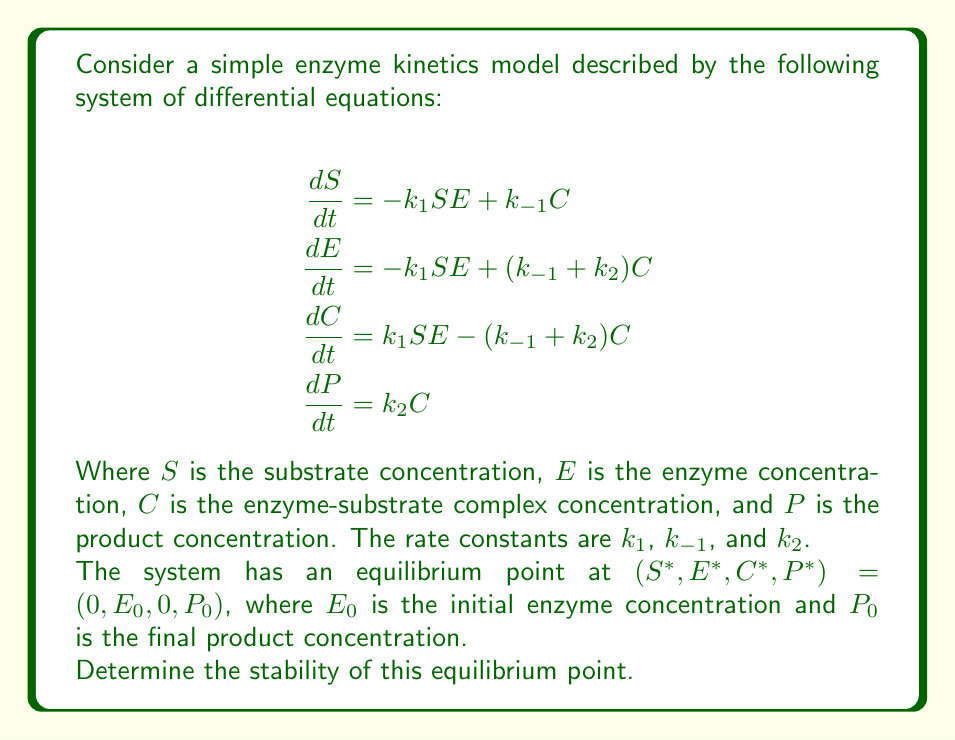Provide a solution to this math problem. To determine the stability of the equilibrium point, we need to follow these steps:

1. Calculate the Jacobian matrix of the system at the equilibrium point.
2. Find the eigenvalues of the Jacobian matrix.
3. Analyze the signs of the real parts of the eigenvalues.

Step 1: Calculate the Jacobian matrix

The Jacobian matrix is:

$$J = \begin{bmatrix}
\frac{\partial \dot{S}}{\partial S} & \frac{\partial \dot{S}}{\partial E} & \frac{\partial \dot{S}}{\partial C} & \frac{\partial \dot{S}}{\partial P} \\
\frac{\partial \dot{E}}{\partial S} & \frac{\partial \dot{E}}{\partial E} & \frac{\partial \dot{E}}{\partial C} & \frac{\partial \dot{E}}{\partial P} \\
\frac{\partial \dot{C}}{\partial S} & \frac{\partial \dot{C}}{\partial E} & \frac{\partial \dot{C}}{\partial C} & \frac{\partial \dot{C}}{\partial P} \\
\frac{\partial \dot{P}}{\partial S} & \frac{\partial \dot{P}}{\partial E} & \frac{\partial \dot{P}}{\partial C} & \frac{\partial \dot{P}}{\partial P}
\end{bmatrix}$$

At the equilibrium point $(0, E_0, 0, P_0)$, the Jacobian becomes:

$$J = \begin{bmatrix}
-k_1E_0 & 0 & k_{-1} & 0 \\
-k_1E_0 & 0 & k_{-1} + k_2 & 0 \\
k_1E_0 & 0 & -(k_{-1} + k_2) & 0 \\
0 & 0 & k_2 & 0
\end{bmatrix}$$

Step 2: Find the eigenvalues

To find the eigenvalues, we need to solve the characteristic equation:

$$\det(J - \lambda I) = 0$$

Expanding this determinant, we get:

$$\lambda^2(\lambda + k_1E_0)(\lambda + k_{-1} + k_2) = 0$$

The eigenvalues are:

$$\lambda_1 = 0 \text{ (double root)}$$
$$\lambda_2 = -k_1E_0$$
$$\lambda_3 = -(k_{-1} + k_2)$$

Step 3: Analyze the eigenvalues

For the equilibrium point to be stable, all eigenvalues must have negative real parts. In this case:

- $\lambda_1 = 0$ (double root): This indicates neutral stability in two directions.
- $\lambda_2 = -k_1E_0$: This is negative since $k_1$ and $E_0$ are positive constants.
- $\lambda_3 = -(k_{-1} + k_2)$: This is negative since $k_{-1}$ and $k_2$ are positive constants.

The presence of zero eigenvalues (neutral stability) means that the equilibrium point is not asymptotically stable. However, it is still considered stable in the sense of Lyapunov, as small perturbations will not cause the system to move away from the equilibrium point indefinitely.
Answer: The equilibrium point is stable but not asymptotically stable (Lyapunov stable). 